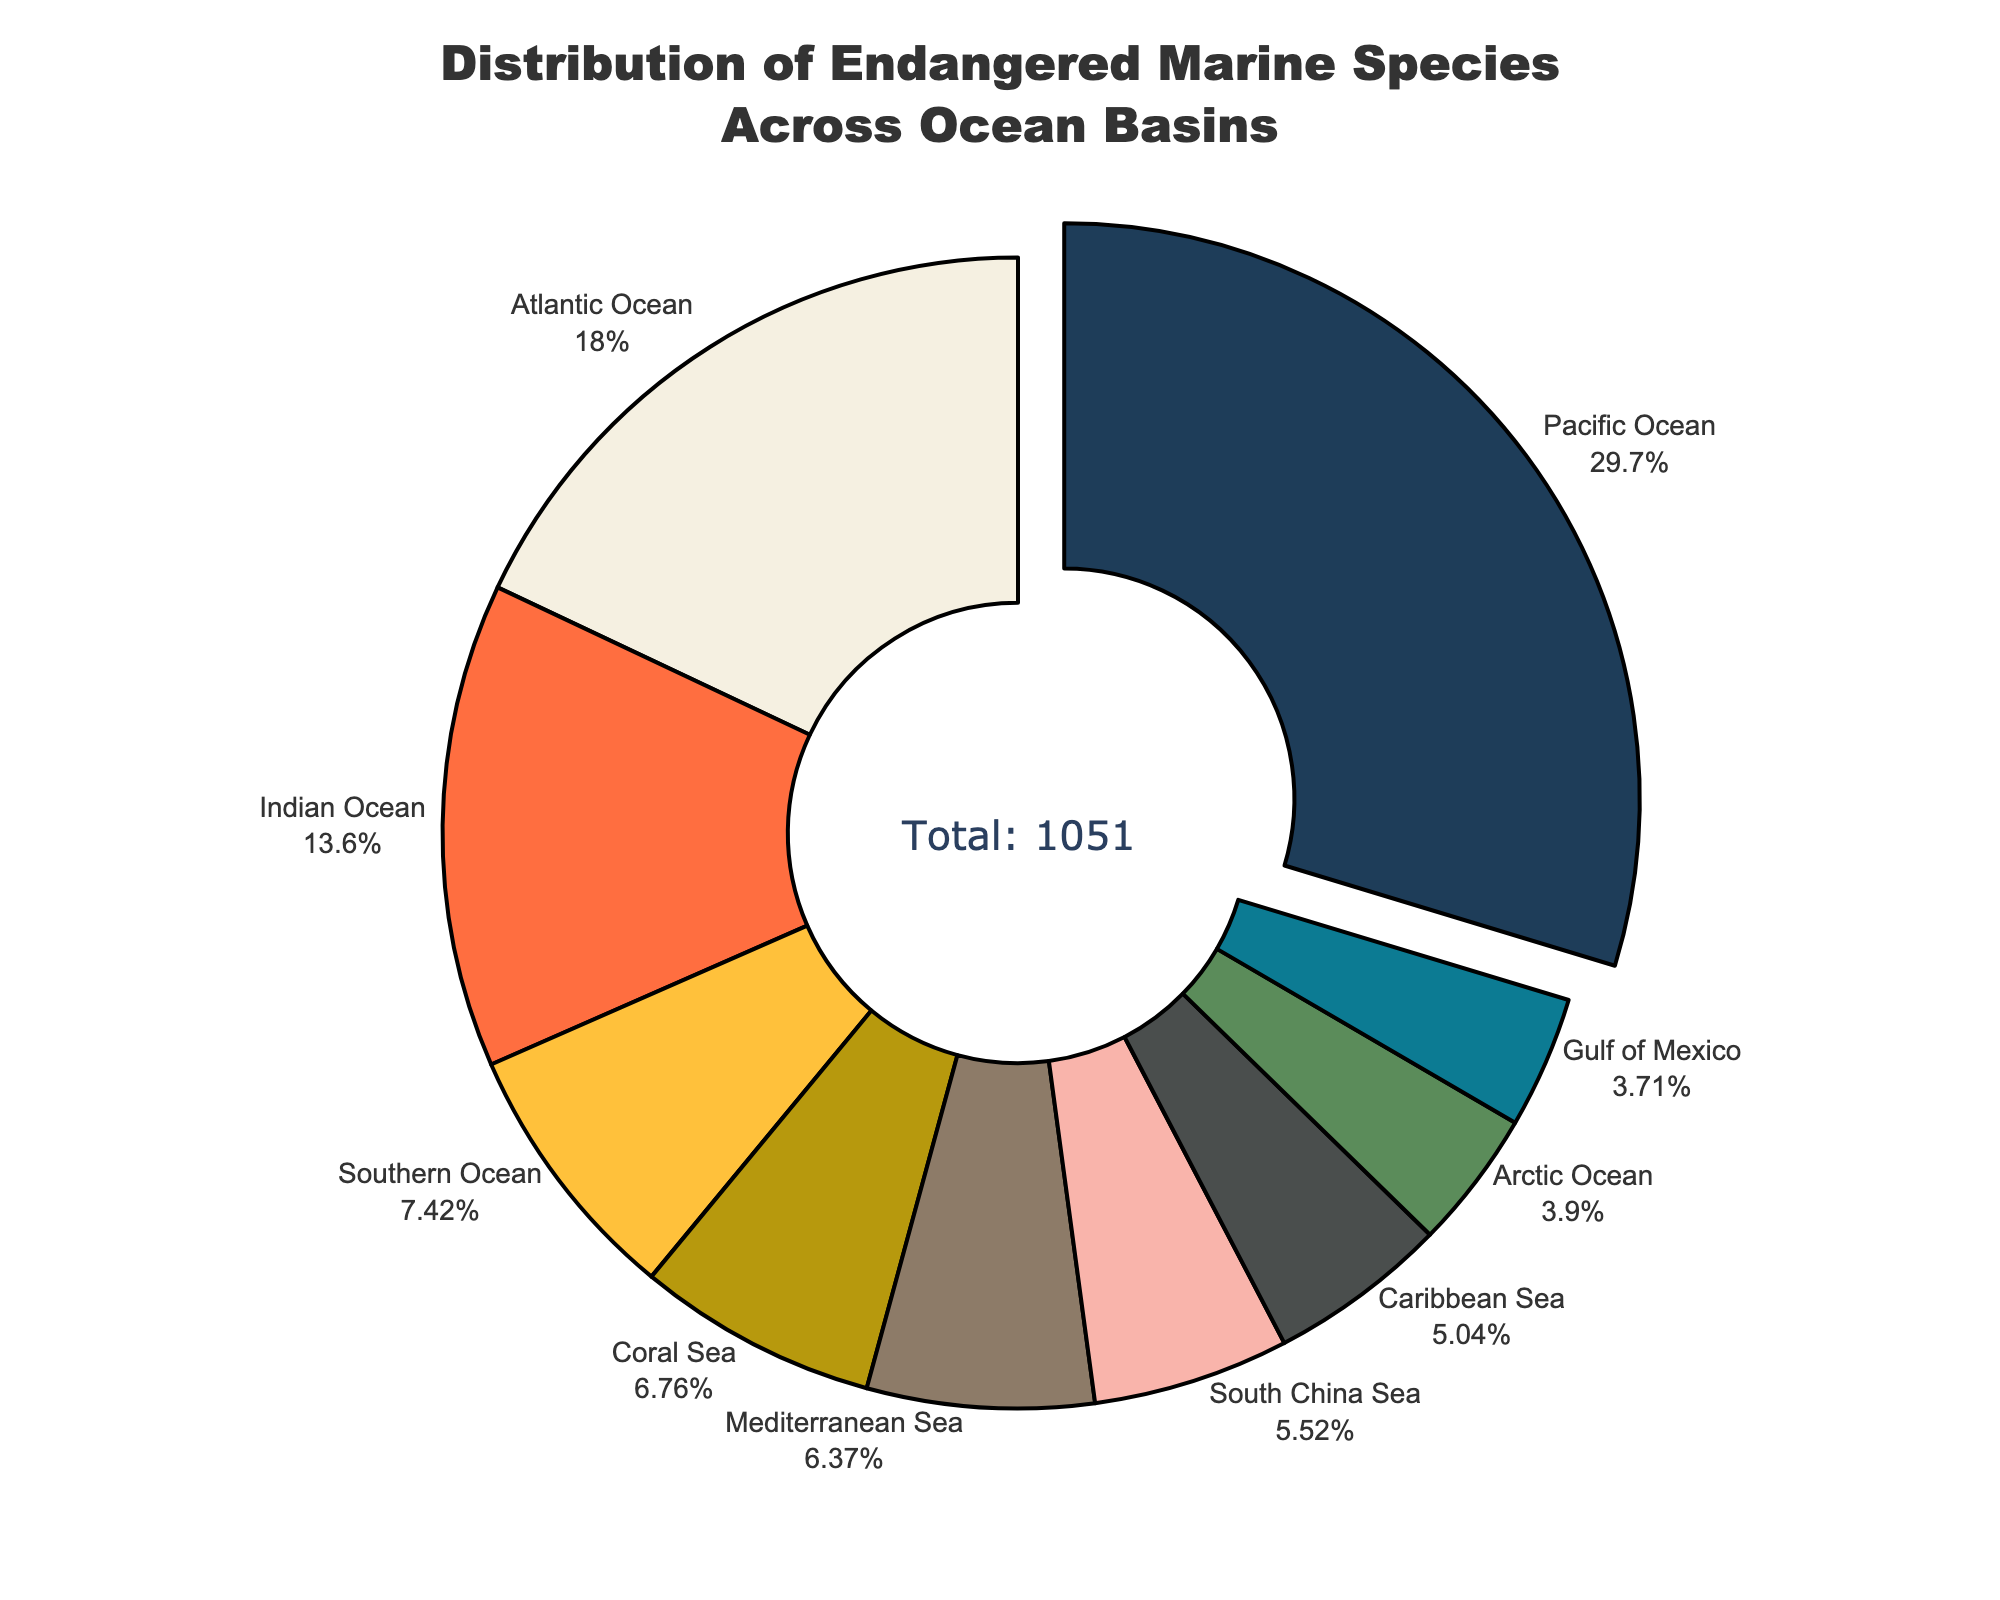Which ocean basin has the highest number of endangered marine species? The pie chart shows that the Pacific Ocean slice is pulled out, indicating it has the highest number of endangered species. The label also shows it has the largest percentage.
Answer: Pacific Ocean What percentage of endangered species are found in the Southern Ocean? The Southern Ocean sector label and percentage displayed outside the pie chart indicates its portion. By visually inspecting the text, we find the percentage.
Answer: 8.7% How does the number of endangered species in the Coral Sea compare to the Mediterranean Sea? By observing the labels outside the pie chart, the Coral Sea has 71 species while the Mediterranean Sea has 67 species. Therefore, the Coral Sea has more endangered species.
Answer: Coral Sea has more What is the combined percentage of endangered species in the Atlantic, Indian, and Southern Oceans? Sum the displayed percentages for these oceans: Atlantic (19.7%) + Indian (14.9%) + Southern (8.1%).
Answer: 42.7% Which ocean basins have similar numbers of endangered species? By examining the size and percentage of each slice, we see that the Mediterranean Sea (67), South China Sea (58), and Coral Sea (71) have relatively similar numbers of endangered species.
Answer: Mediterranean Sea, South China Sea, Coral Sea How many more endangered species are there in the Pacific Ocean compared to the Arctic Ocean? The chart shows the Pacific Ocean has 312 species and the Arctic Ocean has 41 species. Subtracting the two gives 312 - 41 = 271.
Answer: 271 more species What is the total number of endangered species shown in the chart? The annotation in the figure states the total number of endangered species across all ocean basins, which is 1051.
Answer: 1051 Which ocean basin has the smallest number of endangered marine species, and what is this number? The smallest slice with the lowest percentage corresponds to the Gulf of Mexico. The label shows it has 39 endangered species.
Answer: Gulf of Mexico, 39 By what factor is the number of endangered species in the Pacific Ocean greater than that in the Gulf of Mexico? The Pacific Ocean has 312 species and the Gulf of Mexico has 39 species. The factor is calculated as 312/39 = 8.
Answer: 8 times 